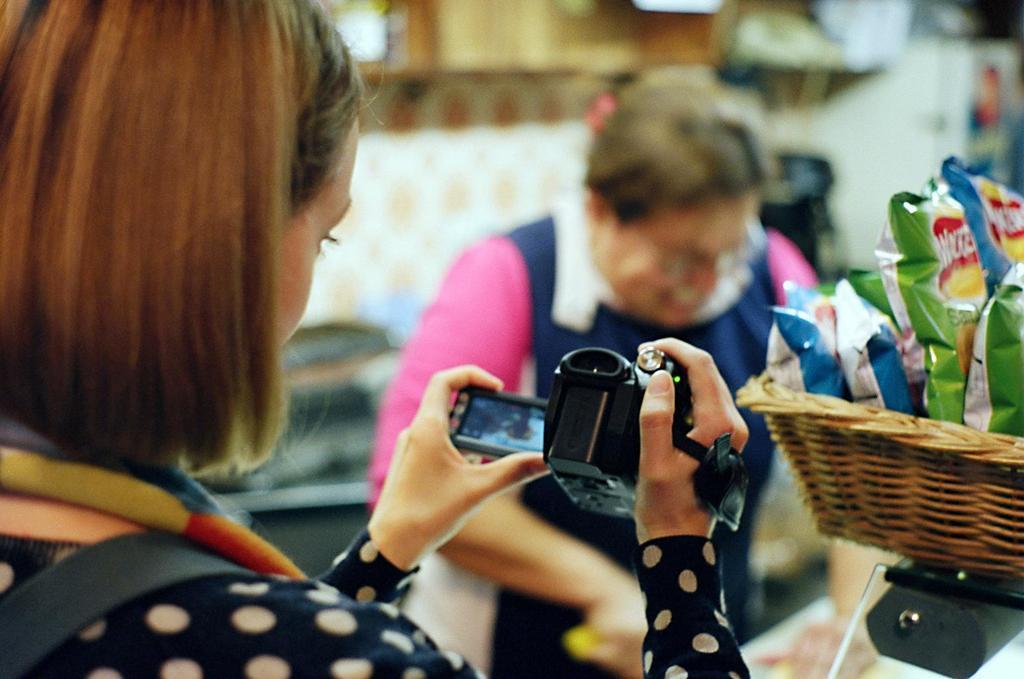Can you describe this image briefly? In this image we can see a lady holding a camera. On the right side there is a basket with packets. In the back there is another person. It is looking blur in the background. 